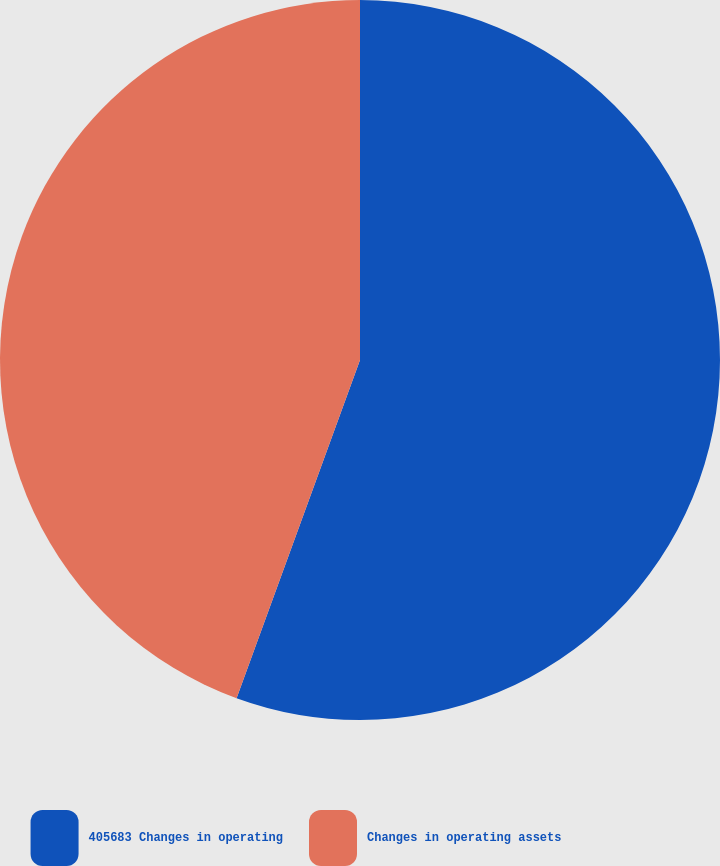<chart> <loc_0><loc_0><loc_500><loc_500><pie_chart><fcel>405683 Changes in operating<fcel>Changes in operating assets<nl><fcel>55.57%<fcel>44.43%<nl></chart> 